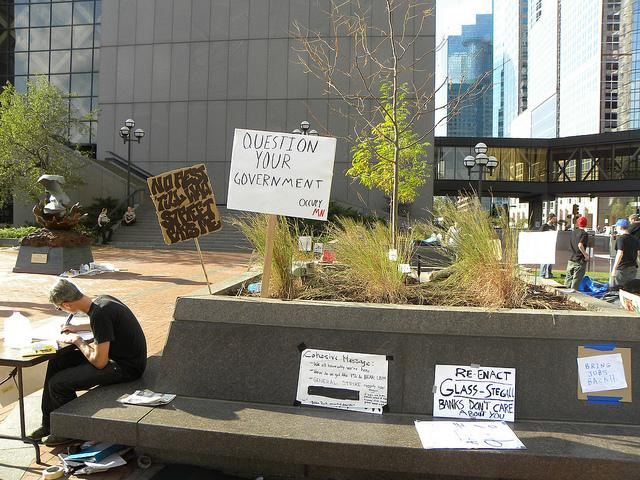What is the man participating in?

Choices:
A) concert
B) sale
C) protest
D) play protest 